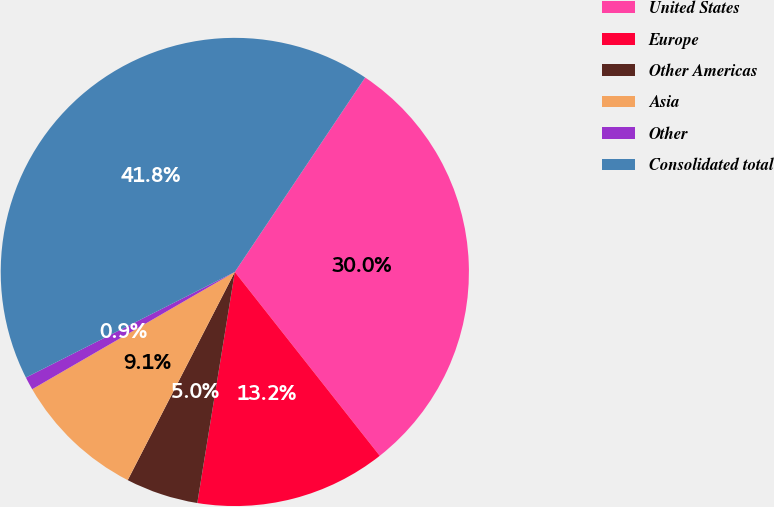<chart> <loc_0><loc_0><loc_500><loc_500><pie_chart><fcel>United States<fcel>Europe<fcel>Other Americas<fcel>Asia<fcel>Other<fcel>Consolidated total<nl><fcel>29.98%<fcel>13.19%<fcel>5.0%<fcel>9.09%<fcel>0.9%<fcel>41.85%<nl></chart> 